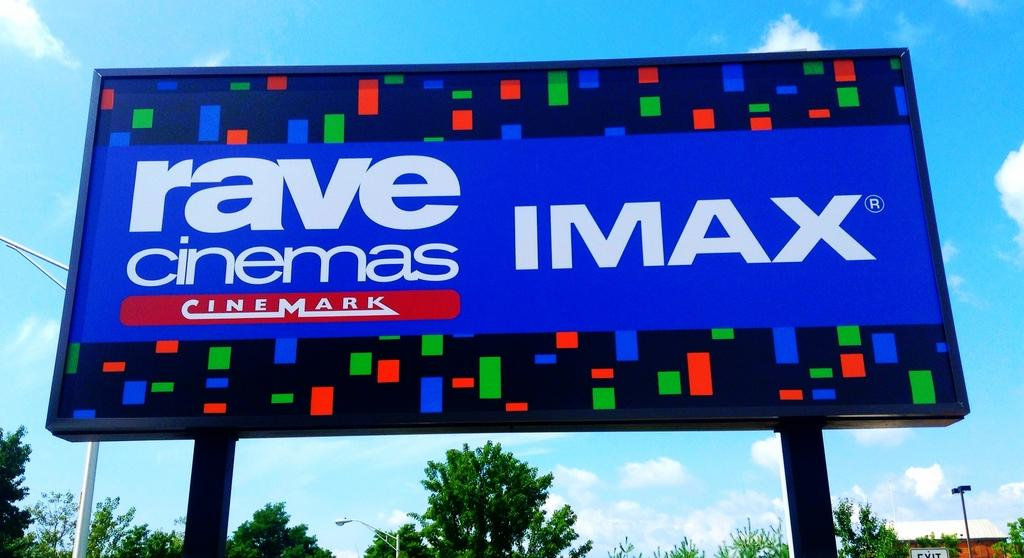<image>
Present a compact description of the photo's key features. a billboard that says 'rave cinemas imax cinermark' on it 